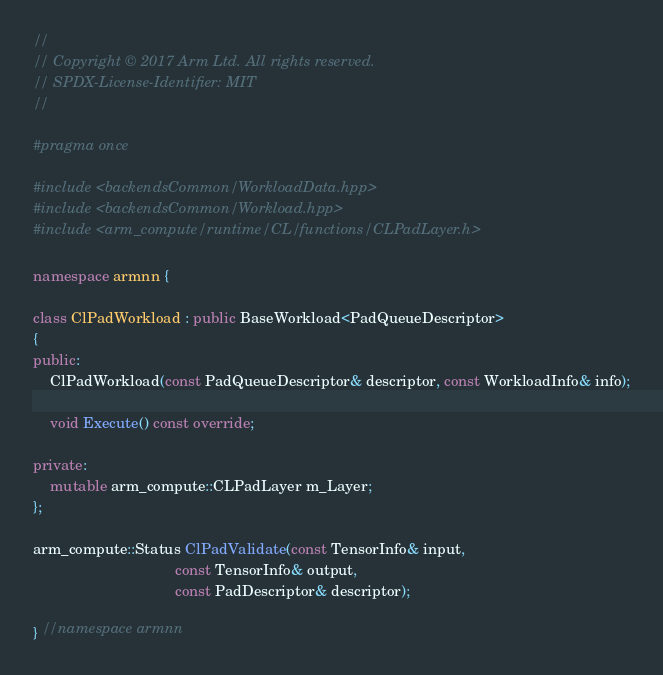<code> <loc_0><loc_0><loc_500><loc_500><_C++_>//
// Copyright © 2017 Arm Ltd. All rights reserved.
// SPDX-License-Identifier: MIT
//

#pragma once

#include <backendsCommon/WorkloadData.hpp>
#include <backendsCommon/Workload.hpp>
#include <arm_compute/runtime/CL/functions/CLPadLayer.h>

namespace armnn {

class ClPadWorkload : public BaseWorkload<PadQueueDescriptor>
{
public:
    ClPadWorkload(const PadQueueDescriptor& descriptor, const WorkloadInfo& info);

    void Execute() const override;

private:
    mutable arm_compute::CLPadLayer m_Layer;
};

arm_compute::Status ClPadValidate(const TensorInfo& input,
                                  const TensorInfo& output,
                                  const PadDescriptor& descriptor);

} //namespace armnn
</code> 